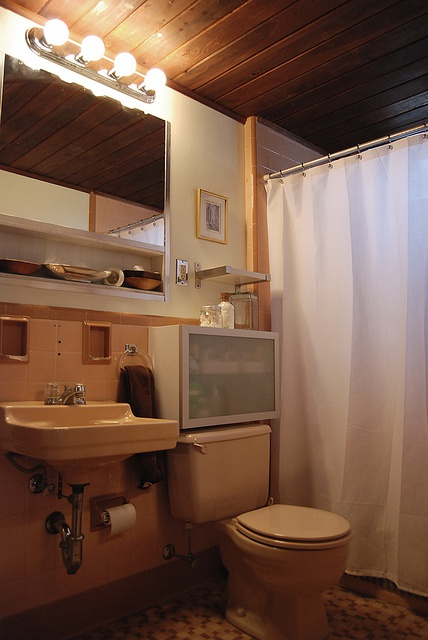Describe the objects in this image and their specific colors. I can see toilet in maroon, black, gray, and brown tones, sink in maroon, brown, and black tones, bowl in maroon, black, and brown tones, and bottle in maroon, tan, and gray tones in this image. 